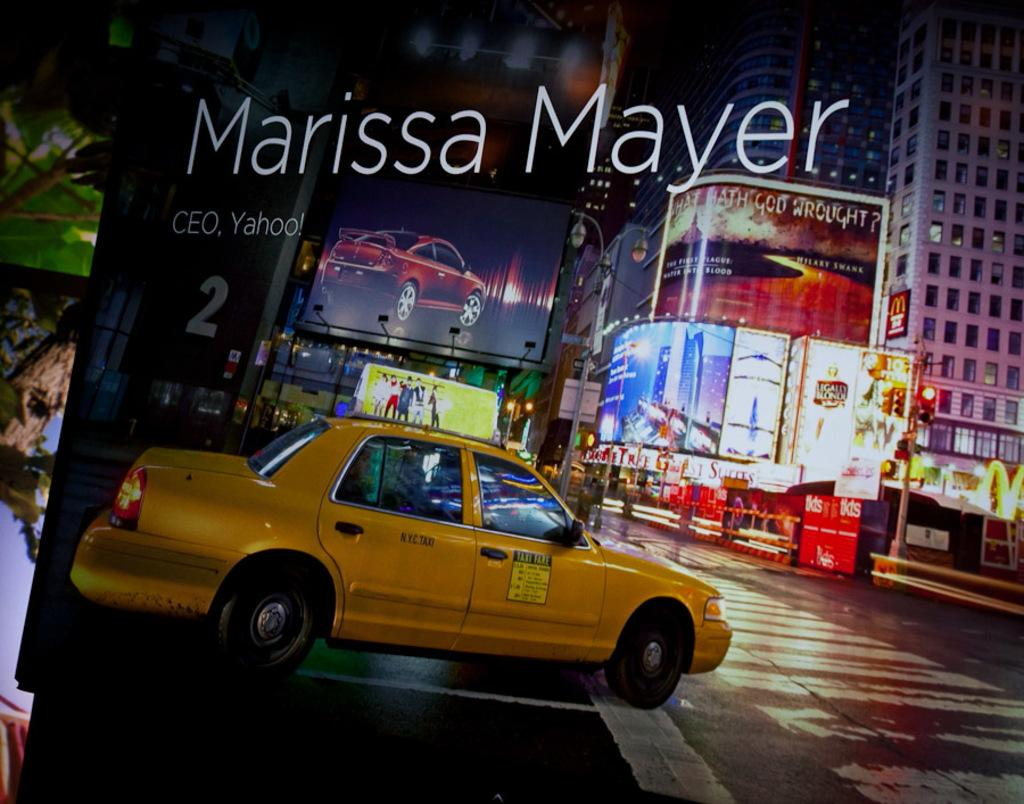Provide a one-sentence caption for the provided image. A taxi waits at a street corner with colorful signs and billboards hanging from tall city buildings. 